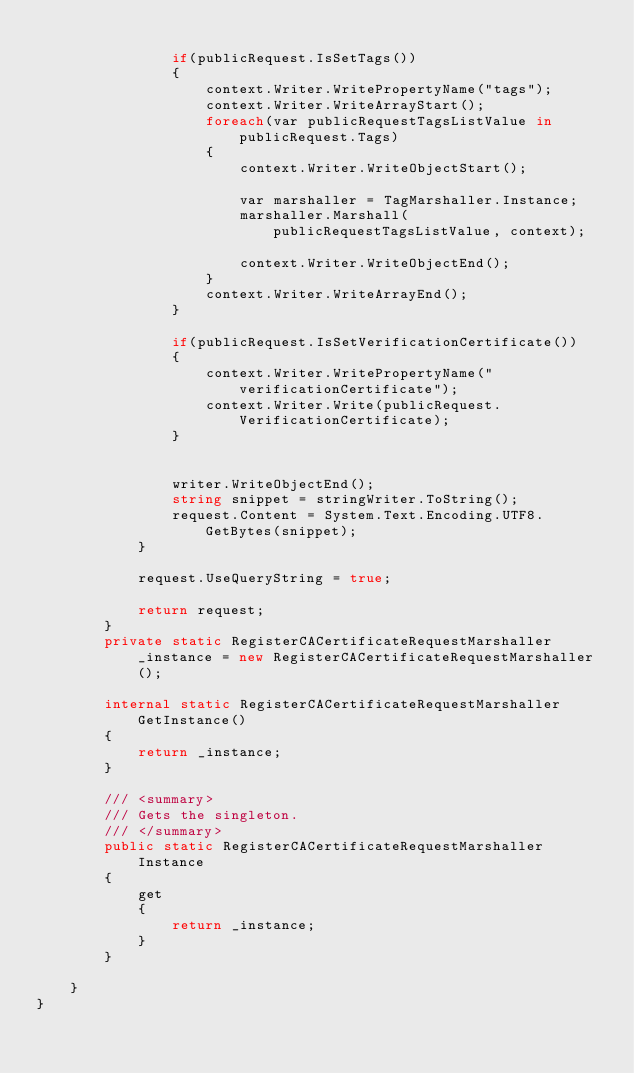Convert code to text. <code><loc_0><loc_0><loc_500><loc_500><_C#_>
                if(publicRequest.IsSetTags())
                {
                    context.Writer.WritePropertyName("tags");
                    context.Writer.WriteArrayStart();
                    foreach(var publicRequestTagsListValue in publicRequest.Tags)
                    {
                        context.Writer.WriteObjectStart();

                        var marshaller = TagMarshaller.Instance;
                        marshaller.Marshall(publicRequestTagsListValue, context);

                        context.Writer.WriteObjectEnd();
                    }
                    context.Writer.WriteArrayEnd();
                }

                if(publicRequest.IsSetVerificationCertificate())
                {
                    context.Writer.WritePropertyName("verificationCertificate");
                    context.Writer.Write(publicRequest.VerificationCertificate);
                }

        
                writer.WriteObjectEnd();
                string snippet = stringWriter.ToString();
                request.Content = System.Text.Encoding.UTF8.GetBytes(snippet);
            }

            request.UseQueryString = true;

            return request;
        }
        private static RegisterCACertificateRequestMarshaller _instance = new RegisterCACertificateRequestMarshaller();        

        internal static RegisterCACertificateRequestMarshaller GetInstance()
        {
            return _instance;
        }

        /// <summary>
        /// Gets the singleton.
        /// </summary>  
        public static RegisterCACertificateRequestMarshaller Instance
        {
            get
            {
                return _instance;
            }
        }

    }
}</code> 